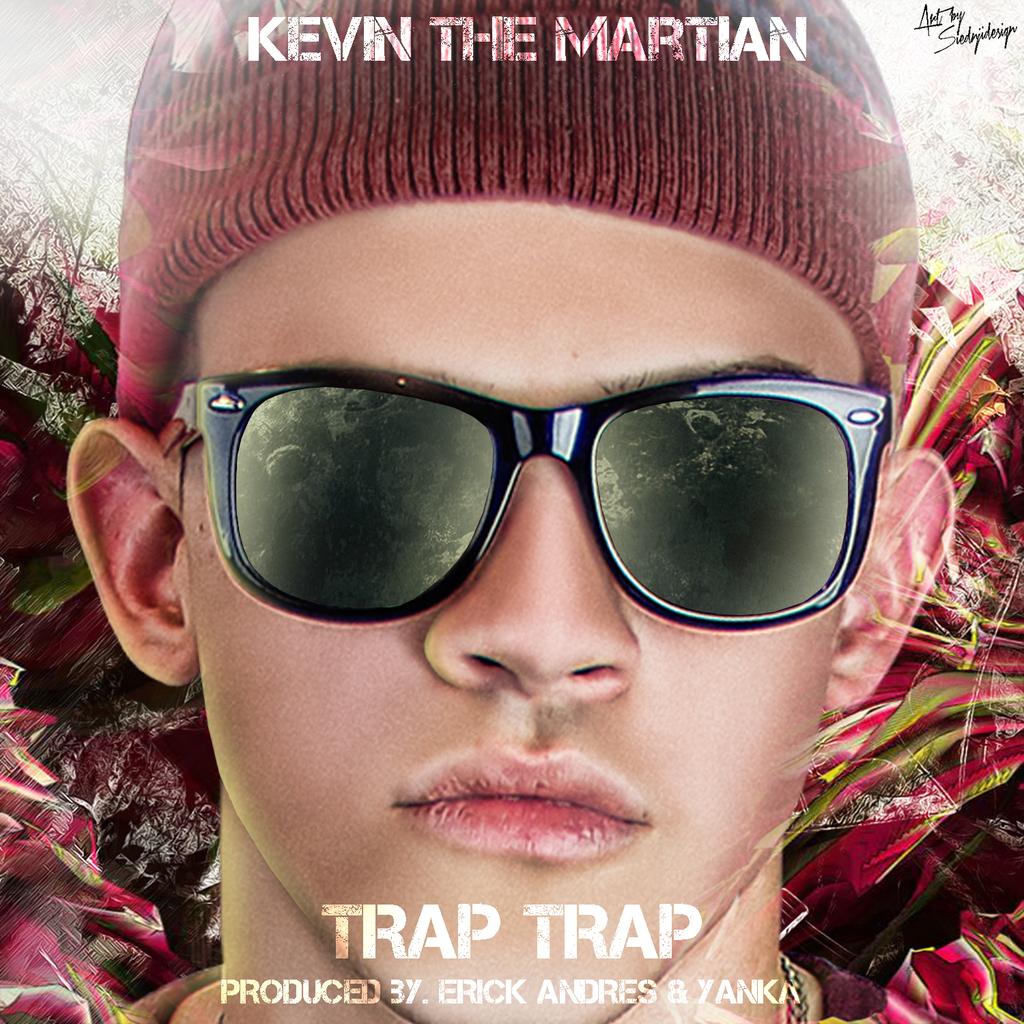What is the title of this musical album?
Offer a very short reply. Trap trap. 